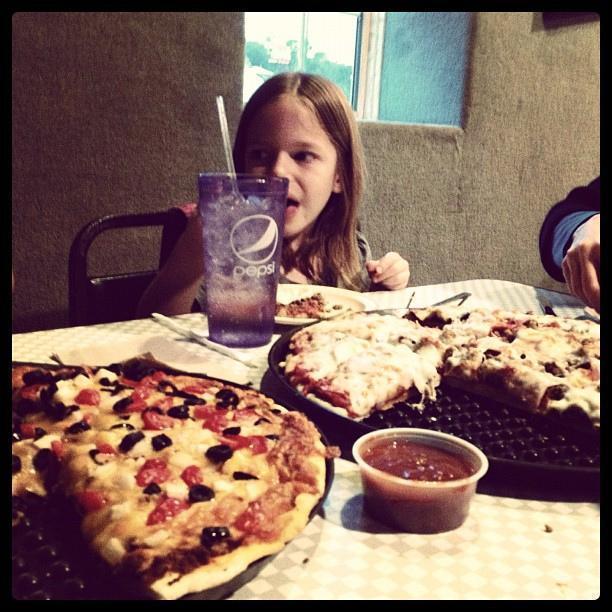What sort of sauce is found in the plastic cup?
Make your selection from the four choices given to correctly answer the question.
Options: Cheese, salsa, marinara, taco. Marinara. 